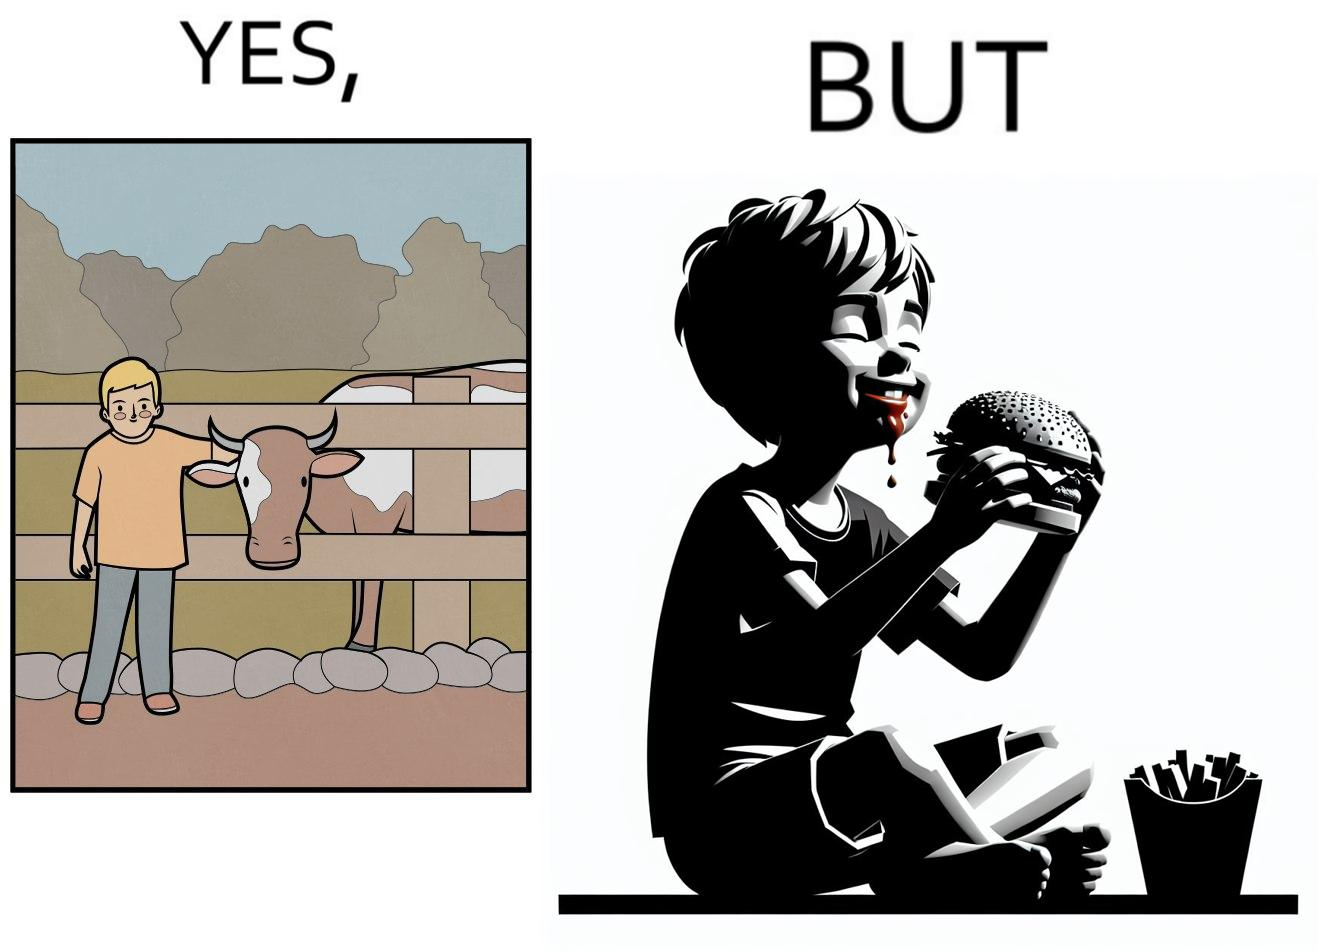Is there satirical content in this image? Yes, this image is satirical. 